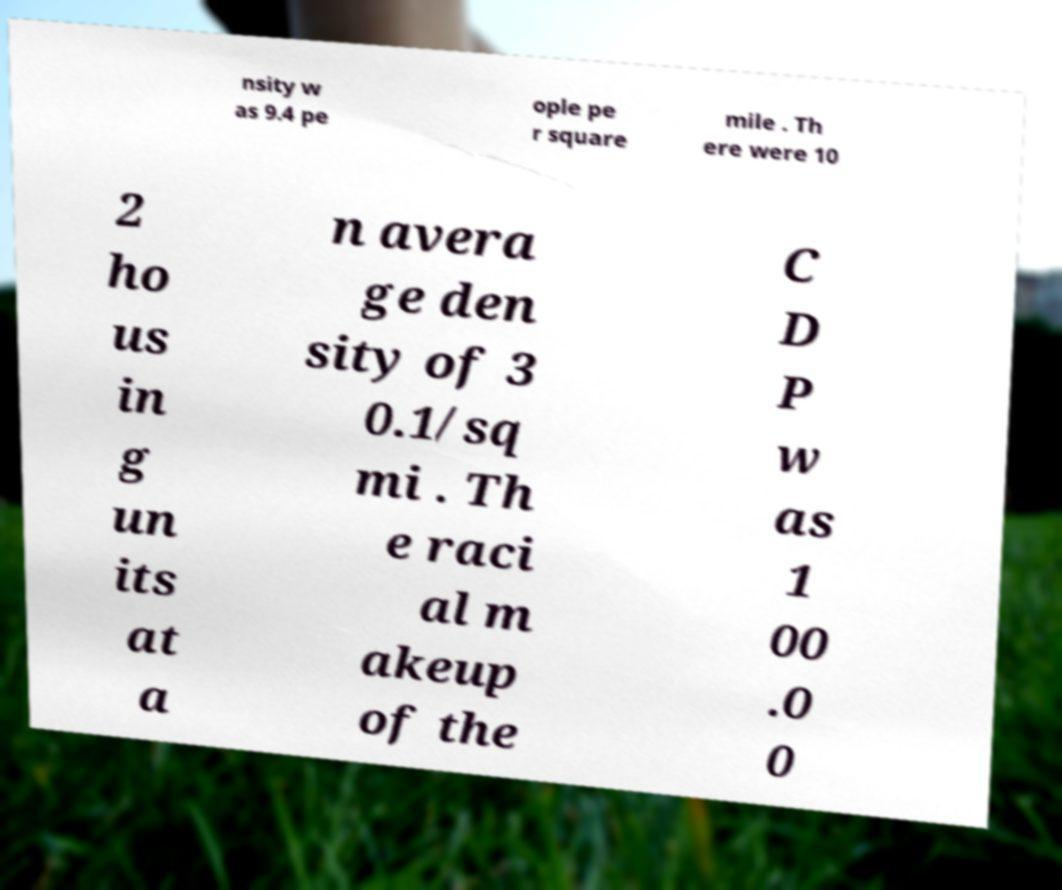Could you extract and type out the text from this image? nsity w as 9.4 pe ople pe r square mile . Th ere were 10 2 ho us in g un its at a n avera ge den sity of 3 0.1/sq mi . Th e raci al m akeup of the C D P w as 1 00 .0 0 